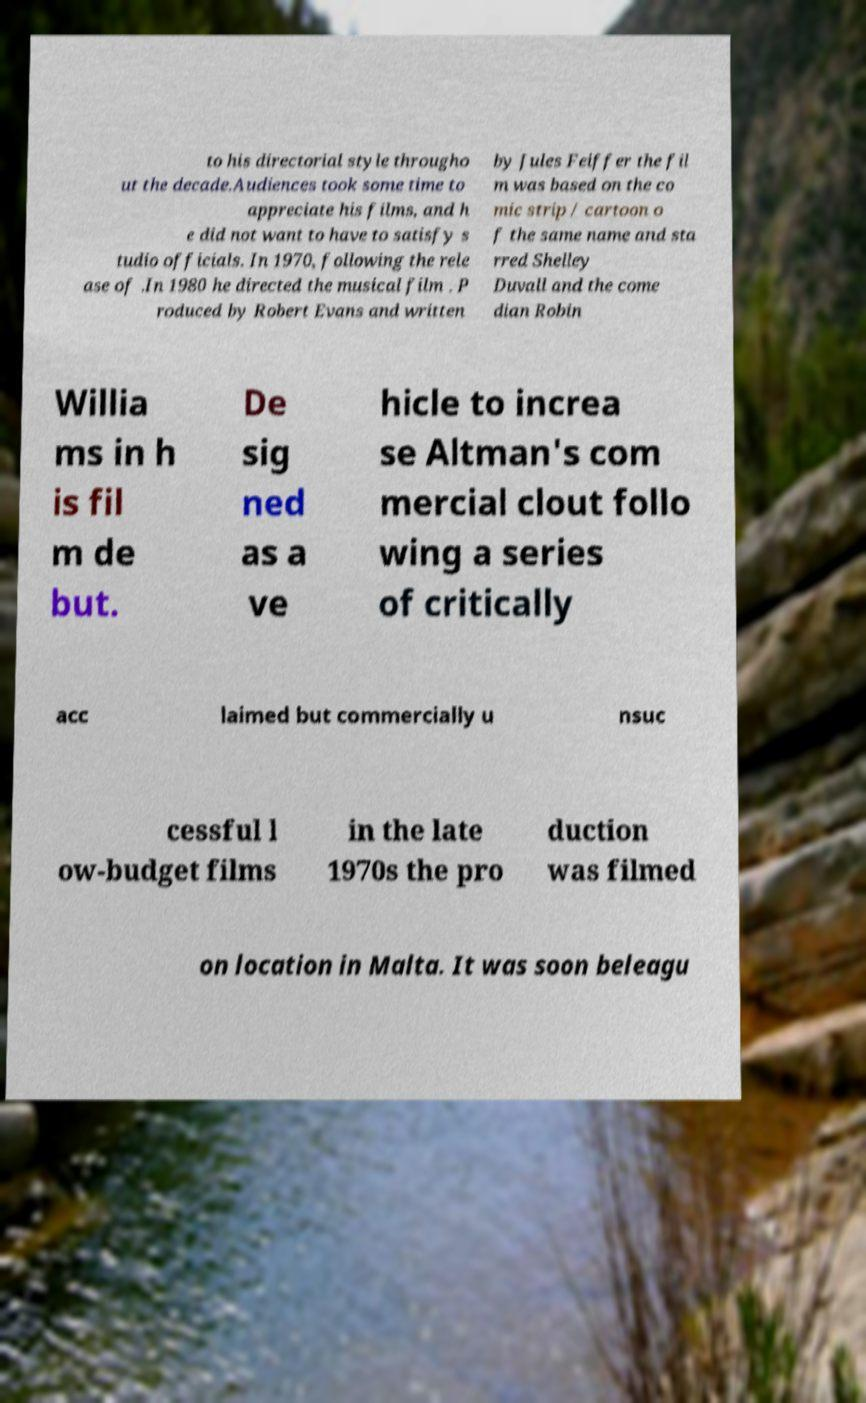Please read and relay the text visible in this image. What does it say? to his directorial style througho ut the decade.Audiences took some time to appreciate his films, and h e did not want to have to satisfy s tudio officials. In 1970, following the rele ase of .In 1980 he directed the musical film . P roduced by Robert Evans and written by Jules Feiffer the fil m was based on the co mic strip / cartoon o f the same name and sta rred Shelley Duvall and the come dian Robin Willia ms in h is fil m de but. De sig ned as a ve hicle to increa se Altman's com mercial clout follo wing a series of critically acc laimed but commercially u nsuc cessful l ow-budget films in the late 1970s the pro duction was filmed on location in Malta. It was soon beleagu 